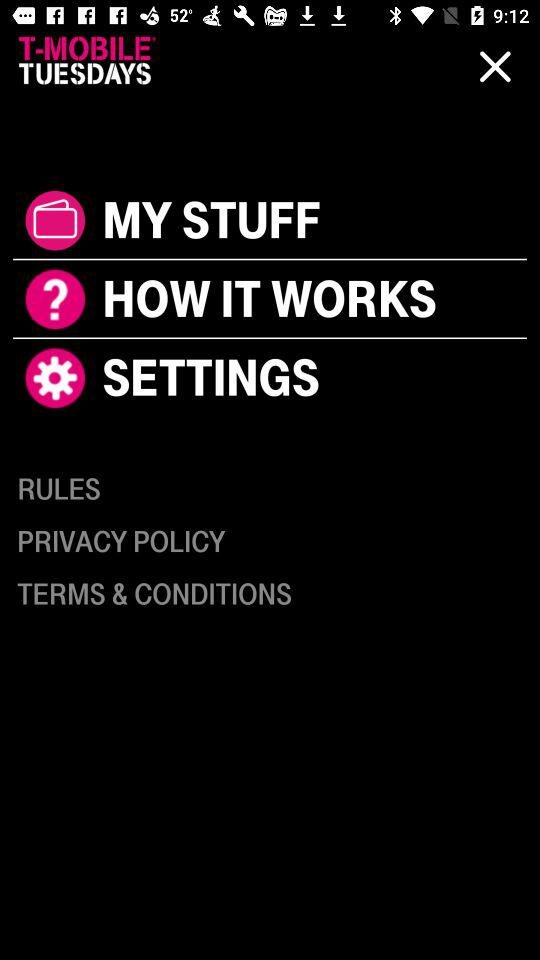What is the selected option? The selected option is "6.4MM". 